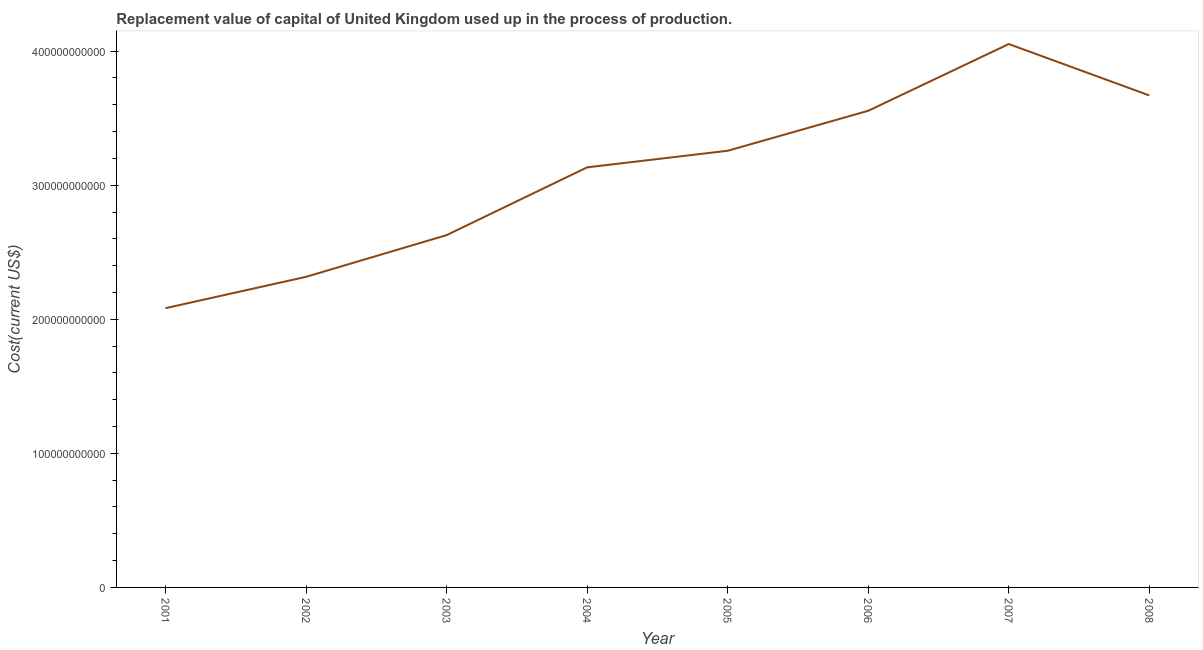What is the consumption of fixed capital in 2005?
Ensure brevity in your answer.  3.26e+11. Across all years, what is the maximum consumption of fixed capital?
Your answer should be very brief. 4.05e+11. Across all years, what is the minimum consumption of fixed capital?
Your answer should be very brief. 2.08e+11. In which year was the consumption of fixed capital maximum?
Give a very brief answer. 2007. What is the sum of the consumption of fixed capital?
Make the answer very short. 2.47e+12. What is the difference between the consumption of fixed capital in 2003 and 2008?
Your answer should be very brief. -1.04e+11. What is the average consumption of fixed capital per year?
Your answer should be compact. 3.09e+11. What is the median consumption of fixed capital?
Your response must be concise. 3.20e+11. In how many years, is the consumption of fixed capital greater than 240000000000 US$?
Your response must be concise. 6. What is the ratio of the consumption of fixed capital in 2002 to that in 2004?
Keep it short and to the point. 0.74. Is the consumption of fixed capital in 2001 less than that in 2002?
Your response must be concise. Yes. What is the difference between the highest and the second highest consumption of fixed capital?
Make the answer very short. 3.83e+1. What is the difference between the highest and the lowest consumption of fixed capital?
Provide a succinct answer. 1.97e+11. What is the difference between two consecutive major ticks on the Y-axis?
Ensure brevity in your answer.  1.00e+11. Does the graph contain any zero values?
Your answer should be compact. No. What is the title of the graph?
Provide a succinct answer. Replacement value of capital of United Kingdom used up in the process of production. What is the label or title of the Y-axis?
Your answer should be compact. Cost(current US$). What is the Cost(current US$) of 2001?
Provide a succinct answer. 2.08e+11. What is the Cost(current US$) of 2002?
Your answer should be very brief. 2.32e+11. What is the Cost(current US$) of 2003?
Keep it short and to the point. 2.63e+11. What is the Cost(current US$) of 2004?
Make the answer very short. 3.13e+11. What is the Cost(current US$) in 2005?
Give a very brief answer. 3.26e+11. What is the Cost(current US$) of 2006?
Offer a terse response. 3.56e+11. What is the Cost(current US$) in 2007?
Provide a succinct answer. 4.05e+11. What is the Cost(current US$) in 2008?
Ensure brevity in your answer.  3.67e+11. What is the difference between the Cost(current US$) in 2001 and 2002?
Keep it short and to the point. -2.34e+1. What is the difference between the Cost(current US$) in 2001 and 2003?
Ensure brevity in your answer.  -5.45e+1. What is the difference between the Cost(current US$) in 2001 and 2004?
Your answer should be very brief. -1.05e+11. What is the difference between the Cost(current US$) in 2001 and 2005?
Offer a terse response. -1.17e+11. What is the difference between the Cost(current US$) in 2001 and 2006?
Keep it short and to the point. -1.47e+11. What is the difference between the Cost(current US$) in 2001 and 2007?
Ensure brevity in your answer.  -1.97e+11. What is the difference between the Cost(current US$) in 2001 and 2008?
Provide a short and direct response. -1.59e+11. What is the difference between the Cost(current US$) in 2002 and 2003?
Ensure brevity in your answer.  -3.11e+1. What is the difference between the Cost(current US$) in 2002 and 2004?
Your response must be concise. -8.17e+1. What is the difference between the Cost(current US$) in 2002 and 2005?
Offer a very short reply. -9.40e+1. What is the difference between the Cost(current US$) in 2002 and 2006?
Offer a terse response. -1.24e+11. What is the difference between the Cost(current US$) in 2002 and 2007?
Make the answer very short. -1.74e+11. What is the difference between the Cost(current US$) in 2002 and 2008?
Your answer should be compact. -1.35e+11. What is the difference between the Cost(current US$) in 2003 and 2004?
Ensure brevity in your answer.  -5.06e+1. What is the difference between the Cost(current US$) in 2003 and 2005?
Ensure brevity in your answer.  -6.29e+1. What is the difference between the Cost(current US$) in 2003 and 2006?
Make the answer very short. -9.27e+1. What is the difference between the Cost(current US$) in 2003 and 2007?
Provide a short and direct response. -1.43e+11. What is the difference between the Cost(current US$) in 2003 and 2008?
Offer a terse response. -1.04e+11. What is the difference between the Cost(current US$) in 2004 and 2005?
Give a very brief answer. -1.24e+1. What is the difference between the Cost(current US$) in 2004 and 2006?
Give a very brief answer. -4.22e+1. What is the difference between the Cost(current US$) in 2004 and 2007?
Keep it short and to the point. -9.20e+1. What is the difference between the Cost(current US$) in 2004 and 2008?
Your answer should be compact. -5.36e+1. What is the difference between the Cost(current US$) in 2005 and 2006?
Provide a short and direct response. -2.98e+1. What is the difference between the Cost(current US$) in 2005 and 2007?
Offer a very short reply. -7.96e+1. What is the difference between the Cost(current US$) in 2005 and 2008?
Keep it short and to the point. -4.13e+1. What is the difference between the Cost(current US$) in 2006 and 2007?
Offer a terse response. -4.98e+1. What is the difference between the Cost(current US$) in 2006 and 2008?
Make the answer very short. -1.15e+1. What is the difference between the Cost(current US$) in 2007 and 2008?
Give a very brief answer. 3.83e+1. What is the ratio of the Cost(current US$) in 2001 to that in 2002?
Keep it short and to the point. 0.9. What is the ratio of the Cost(current US$) in 2001 to that in 2003?
Give a very brief answer. 0.79. What is the ratio of the Cost(current US$) in 2001 to that in 2004?
Provide a short and direct response. 0.67. What is the ratio of the Cost(current US$) in 2001 to that in 2005?
Provide a short and direct response. 0.64. What is the ratio of the Cost(current US$) in 2001 to that in 2006?
Your answer should be very brief. 0.59. What is the ratio of the Cost(current US$) in 2001 to that in 2007?
Your answer should be compact. 0.51. What is the ratio of the Cost(current US$) in 2001 to that in 2008?
Ensure brevity in your answer.  0.57. What is the ratio of the Cost(current US$) in 2002 to that in 2003?
Give a very brief answer. 0.88. What is the ratio of the Cost(current US$) in 2002 to that in 2004?
Give a very brief answer. 0.74. What is the ratio of the Cost(current US$) in 2002 to that in 2005?
Provide a succinct answer. 0.71. What is the ratio of the Cost(current US$) in 2002 to that in 2006?
Ensure brevity in your answer.  0.65. What is the ratio of the Cost(current US$) in 2002 to that in 2007?
Your response must be concise. 0.57. What is the ratio of the Cost(current US$) in 2002 to that in 2008?
Offer a terse response. 0.63. What is the ratio of the Cost(current US$) in 2003 to that in 2004?
Your answer should be compact. 0.84. What is the ratio of the Cost(current US$) in 2003 to that in 2005?
Offer a terse response. 0.81. What is the ratio of the Cost(current US$) in 2003 to that in 2006?
Ensure brevity in your answer.  0.74. What is the ratio of the Cost(current US$) in 2003 to that in 2007?
Provide a short and direct response. 0.65. What is the ratio of the Cost(current US$) in 2003 to that in 2008?
Provide a succinct answer. 0.72. What is the ratio of the Cost(current US$) in 2004 to that in 2006?
Your answer should be compact. 0.88. What is the ratio of the Cost(current US$) in 2004 to that in 2007?
Your answer should be compact. 0.77. What is the ratio of the Cost(current US$) in 2004 to that in 2008?
Give a very brief answer. 0.85. What is the ratio of the Cost(current US$) in 2005 to that in 2006?
Your answer should be compact. 0.92. What is the ratio of the Cost(current US$) in 2005 to that in 2007?
Your answer should be compact. 0.8. What is the ratio of the Cost(current US$) in 2005 to that in 2008?
Ensure brevity in your answer.  0.89. What is the ratio of the Cost(current US$) in 2006 to that in 2007?
Ensure brevity in your answer.  0.88. What is the ratio of the Cost(current US$) in 2007 to that in 2008?
Offer a very short reply. 1.1. 